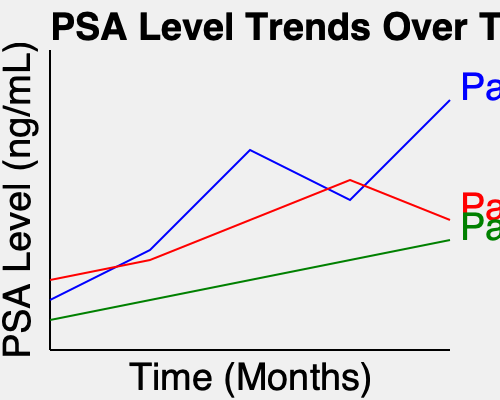Based on the PSA level charts for three patients over a 12-month period, which patient shows the most concerning trend in terms of potential prostate cancer progression? To determine which patient shows the most concerning trend, we need to analyze the PSA level changes for each patient:

1. Patient A (blue line):
   - Starting PSA: ~2.5 ng/mL
   - Ending PSA: ~12.5 ng/mL
   - Overall trend: Significant increase with some fluctuations

2. Patient B (red line):
   - Starting PSA: ~3.5 ng/mL
   - Ending PSA: ~6.5 ng/mL
   - Overall trend: Gradual increase

3. Patient C (green line):
   - Starting PSA: ~1.5 ng/mL
   - Ending PSA: ~5.5 ng/mL
   - Overall trend: Steady, slow increase

Analyzing these trends:

1. Patient A shows the most dramatic increase in PSA levels, rising from ~2.5 ng/mL to ~12.5 ng/mL over 12 months. This represents a 5-fold increase.
2. Patient B shows a moderate increase from ~3.5 ng/mL to ~6.5 ng/mL, almost doubling over the period.
3. Patient C shows the slowest increase, from ~1.5 ng/mL to ~5.5 ng/mL, but still more than tripling over time.

In prostate cancer monitoring, rapid increases in PSA levels are generally more concerning than gradual increases. A PSA velocity (rate of change) greater than 0.75 ng/mL per year is often considered worrisome.

Patient A's PSA increased by approximately 10 ng/mL in 12 months, far exceeding this threshold. This rapid rise suggests a more aggressive progression of prostate cancer compared to the other patients.
Answer: Patient A 